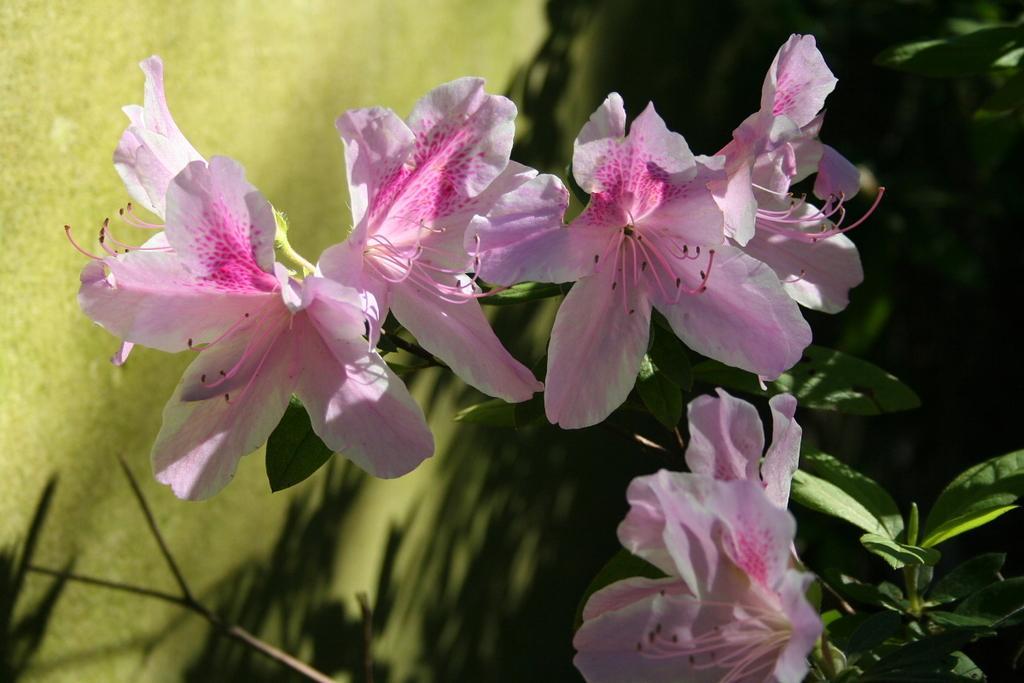Can you describe this image briefly? In the image there are beautiful pink flowers to the plant and the background of the flowers is blur. 